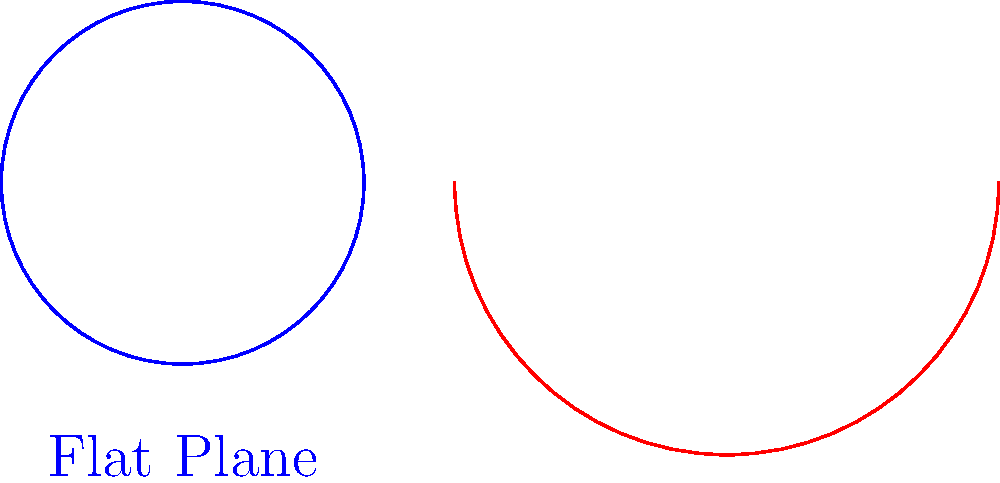Imagine the U.S. Sassuolo Calcio logo is painted as a circle with radius $r$ on both a flat surface (like their home pitch) and on a sphere with radius $R$, where $r < R$. How does the area of the logo on the sphere compare to its area on the flat surface? Let's approach this step-by-step:

1) On a flat surface (Euclidean geometry), the area of a circle with radius $r$ is given by:
   $$A_{flat} = \pi r^2$$

2) On a sphere (non-Euclidean geometry), the area of a circle with radius $r$ is given by:
   $$A_{sphere} = 2\pi R^2 (1 - \cos(\frac{r}{R}))$$
   Where $R$ is the radius of the sphere and $r$ is the radius of the circle on the sphere's surface.

3) We can expand the cosine term using Taylor series:
   $$\cos(\frac{r}{R}) \approx 1 - \frac{1}{2}(\frac{r}{R})^2 + \frac{1}{24}(\frac{r}{R})^4 - ...$$

4) Substituting this into the sphere area formula:
   $$A_{sphere} \approx 2\pi R^2 (1 - (1 - \frac{1}{2}(\frac{r}{R})^2 + \frac{1}{24}(\frac{r}{R})^4 - ...))$$
   $$A_{sphere} \approx 2\pi R^2 (\frac{1}{2}(\frac{r}{R})^2 - \frac{1}{24}(\frac{r}{R})^4 + ...)$$
   $$A_{sphere} \approx \pi r^2 (1 - \frac{1}{12}(\frac{r}{R})^2 + ...)$$

5) Comparing this to the flat surface area:
   $$A_{sphere} \approx A_{flat} (1 - \frac{1}{12}(\frac{r}{R})^2 + ...)$$

6) Since $r < R$, the term $\frac{1}{12}(\frac{r}{R})^2$ is positive but less than 1.

Therefore, the area of the logo on the sphere is slightly smaller than on the flat surface.
Answer: Slightly smaller on the sphere 